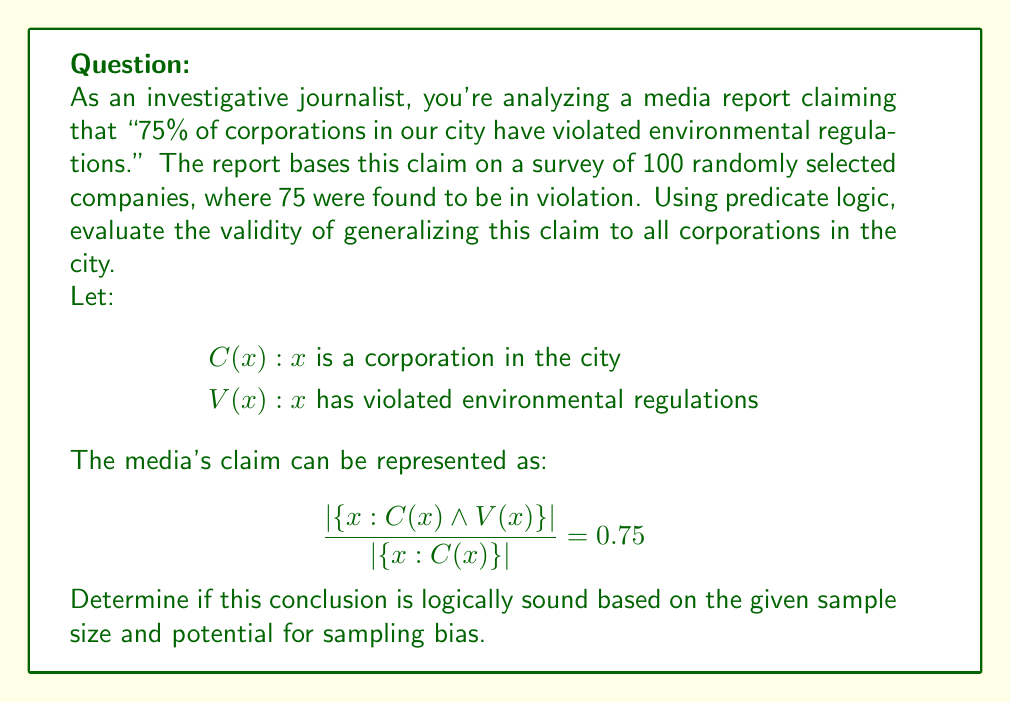Give your solution to this math problem. To evaluate the validity of this claim using predicate logic, we need to consider several factors:

1. Sample size and population:
   The sample size (n = 100) is relatively small compared to the total number of corporations in a city. Let's assume the city has 1000 corporations.

2. Confidence interval:
   We can calculate the margin of error for a 95% confidence level using the formula:
   $$\text{Margin of Error} = 1.96 \times \sqrt{\frac{p(1-p)}{n}}$$
   Where p is the sample proportion (0.75) and n is the sample size (100).

   $$\text{Margin of Error} = 1.96 \times \sqrt{\frac{0.75(1-0.75)}{100}} \approx 0.085$$

3. Logical representation:
   The claim implies that for any corporation x in the city:
   $$\forall x (C(x) \rightarrow P(V(x)) = 0.75)$$
   Where P(V(x)) is the probability that x has violated regulations.

4. Sampling bias:
   The report doesn't mention the sampling method, which could introduce bias. A truly random sample would be represented as:
   $$\forall x (C(x) \rightarrow P(\text{selected}(x)) = \frac{100}{1000})$$

5. Generalization:
   The sample proportion (75%) with a margin of error of 8.5% gives us a range of 66.5% to 83.5% for the true population proportion. This assumes no sampling bias and a large enough population.

6. Logical conclusion:
   We cannot definitively conclude that exactly 75% of all corporations have violated regulations. A more accurate logical statement would be:
   $$\exists p (0.665 \leq p \leq 0.835 \land \forall x (C(x) \rightarrow P(V(x)) = p))$$

This statement asserts that there exists a proportion p between 66.5% and 83.5% such that for all corporations x in the city, the probability of x violating regulations is equal to p.
Answer: The claim is not logically sound as stated. A more accurate representation is: $$\exists p (0.665 \leq p \leq 0.835 \land \forall x (C(x) \rightarrow P(V(x)) = p))$$ 